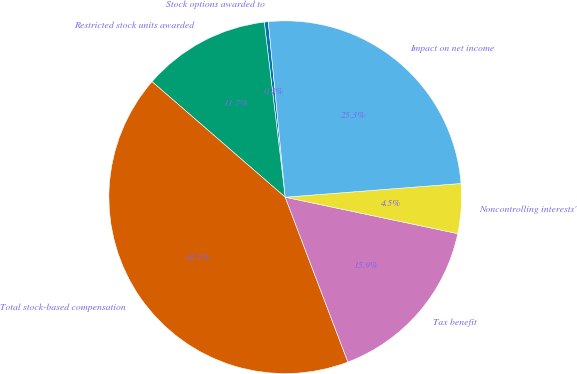Convert chart. <chart><loc_0><loc_0><loc_500><loc_500><pie_chart><fcel>Stock options awarded to<fcel>Restricted stock units awarded<fcel>Total stock-based compensation<fcel>Tax benefit<fcel>Noncontrolling interests'<fcel>Impact on net income<nl><fcel>0.37%<fcel>11.73%<fcel>42.16%<fcel>15.91%<fcel>4.55%<fcel>25.29%<nl></chart> 